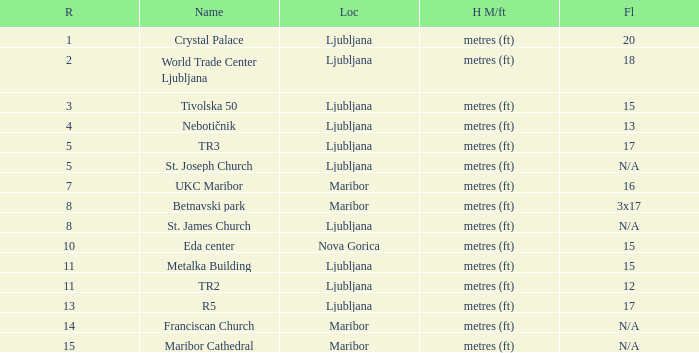Which Floors have a Location of ljubljana, and a Name of tr3? 17.0. 